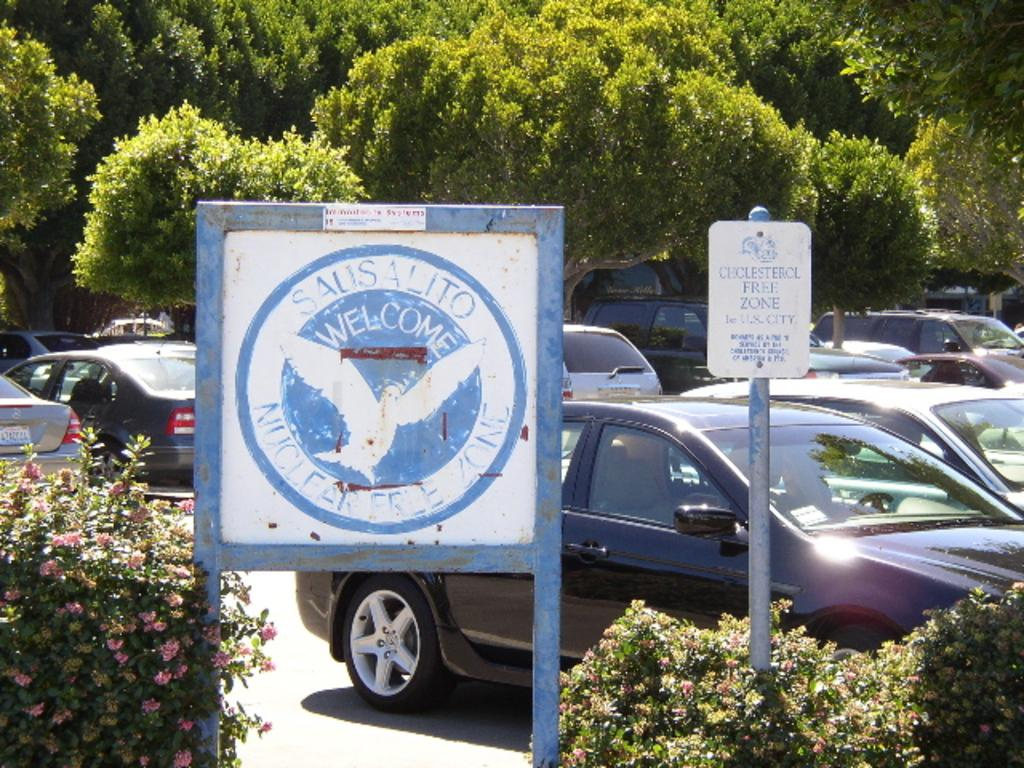What type of vehicles can be seen in the image? There are cars in the image. What structures are present in the image? There are poles and boards in the image. What type of vegetation is visible in the image? There are plants, flowers, and trees in the image. What type of tax is being discussed in the image? There is no discussion of tax in the image; it features cars, poles, boards, plants, flowers, and trees. Can you tell me who signed the agreement in the image? There is no agreement or signature present in the image. 